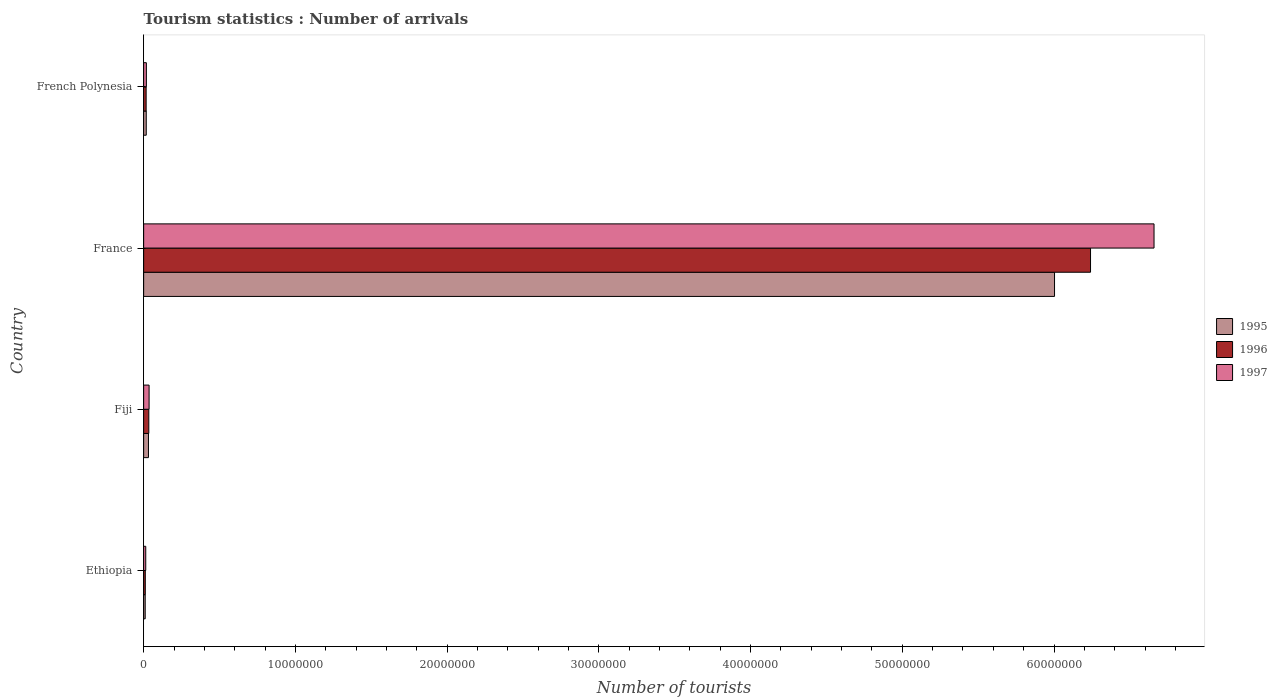Are the number of bars per tick equal to the number of legend labels?
Provide a succinct answer. Yes. How many bars are there on the 4th tick from the top?
Make the answer very short. 3. How many bars are there on the 1st tick from the bottom?
Give a very brief answer. 3. What is the label of the 1st group of bars from the top?
Make the answer very short. French Polynesia. In how many cases, is the number of bars for a given country not equal to the number of legend labels?
Give a very brief answer. 0. What is the number of tourist arrivals in 1995 in France?
Provide a succinct answer. 6.00e+07. Across all countries, what is the maximum number of tourist arrivals in 1996?
Provide a succinct answer. 6.24e+07. Across all countries, what is the minimum number of tourist arrivals in 1995?
Offer a terse response. 1.03e+05. In which country was the number of tourist arrivals in 1996 maximum?
Provide a succinct answer. France. In which country was the number of tourist arrivals in 1995 minimum?
Give a very brief answer. Ethiopia. What is the total number of tourist arrivals in 1996 in the graph?
Offer a terse response. 6.30e+07. What is the difference between the number of tourist arrivals in 1996 in Fiji and that in French Polynesia?
Ensure brevity in your answer.  1.76e+05. What is the difference between the number of tourist arrivals in 1995 in Fiji and the number of tourist arrivals in 1996 in French Polynesia?
Your answer should be very brief. 1.54e+05. What is the average number of tourist arrivals in 1996 per country?
Make the answer very short. 1.58e+07. What is the difference between the number of tourist arrivals in 1996 and number of tourist arrivals in 1995 in Fiji?
Your answer should be very brief. 2.20e+04. What is the ratio of the number of tourist arrivals in 1996 in Ethiopia to that in France?
Your response must be concise. 0. What is the difference between the highest and the second highest number of tourist arrivals in 1997?
Provide a short and direct response. 6.62e+07. What is the difference between the highest and the lowest number of tourist arrivals in 1997?
Your answer should be compact. 6.65e+07. Is the sum of the number of tourist arrivals in 1997 in Fiji and French Polynesia greater than the maximum number of tourist arrivals in 1995 across all countries?
Give a very brief answer. No. How many bars are there?
Your response must be concise. 12. Are all the bars in the graph horizontal?
Ensure brevity in your answer.  Yes. How many countries are there in the graph?
Your answer should be very brief. 4. What is the difference between two consecutive major ticks on the X-axis?
Make the answer very short. 1.00e+07. Does the graph contain grids?
Provide a short and direct response. No. How many legend labels are there?
Give a very brief answer. 3. What is the title of the graph?
Your answer should be very brief. Tourism statistics : Number of arrivals. Does "1973" appear as one of the legend labels in the graph?
Offer a very short reply. No. What is the label or title of the X-axis?
Your response must be concise. Number of tourists. What is the Number of tourists of 1995 in Ethiopia?
Make the answer very short. 1.03e+05. What is the Number of tourists of 1996 in Ethiopia?
Keep it short and to the point. 1.09e+05. What is the Number of tourists of 1997 in Ethiopia?
Keep it short and to the point. 1.39e+05. What is the Number of tourists in 1995 in Fiji?
Ensure brevity in your answer.  3.18e+05. What is the Number of tourists in 1997 in Fiji?
Make the answer very short. 3.59e+05. What is the Number of tourists of 1995 in France?
Give a very brief answer. 6.00e+07. What is the Number of tourists of 1996 in France?
Your answer should be very brief. 6.24e+07. What is the Number of tourists in 1997 in France?
Ensure brevity in your answer.  6.66e+07. What is the Number of tourists of 1995 in French Polynesia?
Offer a terse response. 1.72e+05. What is the Number of tourists of 1996 in French Polynesia?
Provide a succinct answer. 1.64e+05. What is the Number of tourists of 1997 in French Polynesia?
Your response must be concise. 1.80e+05. Across all countries, what is the maximum Number of tourists of 1995?
Provide a short and direct response. 6.00e+07. Across all countries, what is the maximum Number of tourists of 1996?
Make the answer very short. 6.24e+07. Across all countries, what is the maximum Number of tourists in 1997?
Make the answer very short. 6.66e+07. Across all countries, what is the minimum Number of tourists in 1995?
Give a very brief answer. 1.03e+05. Across all countries, what is the minimum Number of tourists in 1996?
Your answer should be very brief. 1.09e+05. Across all countries, what is the minimum Number of tourists in 1997?
Make the answer very short. 1.39e+05. What is the total Number of tourists of 1995 in the graph?
Ensure brevity in your answer.  6.06e+07. What is the total Number of tourists in 1996 in the graph?
Your response must be concise. 6.30e+07. What is the total Number of tourists of 1997 in the graph?
Provide a short and direct response. 6.73e+07. What is the difference between the Number of tourists in 1995 in Ethiopia and that in Fiji?
Your answer should be compact. -2.15e+05. What is the difference between the Number of tourists of 1996 in Ethiopia and that in Fiji?
Your answer should be very brief. -2.31e+05. What is the difference between the Number of tourists in 1995 in Ethiopia and that in France?
Your answer should be very brief. -5.99e+07. What is the difference between the Number of tourists of 1996 in Ethiopia and that in France?
Make the answer very short. -6.23e+07. What is the difference between the Number of tourists of 1997 in Ethiopia and that in France?
Provide a succinct answer. -6.65e+07. What is the difference between the Number of tourists in 1995 in Ethiopia and that in French Polynesia?
Offer a very short reply. -6.90e+04. What is the difference between the Number of tourists of 1996 in Ethiopia and that in French Polynesia?
Keep it short and to the point. -5.50e+04. What is the difference between the Number of tourists in 1997 in Ethiopia and that in French Polynesia?
Give a very brief answer. -4.10e+04. What is the difference between the Number of tourists of 1995 in Fiji and that in France?
Your answer should be compact. -5.97e+07. What is the difference between the Number of tourists in 1996 in Fiji and that in France?
Your response must be concise. -6.21e+07. What is the difference between the Number of tourists in 1997 in Fiji and that in France?
Ensure brevity in your answer.  -6.62e+07. What is the difference between the Number of tourists in 1995 in Fiji and that in French Polynesia?
Your answer should be compact. 1.46e+05. What is the difference between the Number of tourists of 1996 in Fiji and that in French Polynesia?
Keep it short and to the point. 1.76e+05. What is the difference between the Number of tourists of 1997 in Fiji and that in French Polynesia?
Offer a terse response. 1.79e+05. What is the difference between the Number of tourists of 1995 in France and that in French Polynesia?
Provide a short and direct response. 5.99e+07. What is the difference between the Number of tourists in 1996 in France and that in French Polynesia?
Your answer should be very brief. 6.22e+07. What is the difference between the Number of tourists of 1997 in France and that in French Polynesia?
Give a very brief answer. 6.64e+07. What is the difference between the Number of tourists of 1995 in Ethiopia and the Number of tourists of 1996 in Fiji?
Make the answer very short. -2.37e+05. What is the difference between the Number of tourists in 1995 in Ethiopia and the Number of tourists in 1997 in Fiji?
Ensure brevity in your answer.  -2.56e+05. What is the difference between the Number of tourists of 1996 in Ethiopia and the Number of tourists of 1997 in Fiji?
Your answer should be very brief. -2.50e+05. What is the difference between the Number of tourists of 1995 in Ethiopia and the Number of tourists of 1996 in France?
Your answer should be compact. -6.23e+07. What is the difference between the Number of tourists in 1995 in Ethiopia and the Number of tourists in 1997 in France?
Offer a very short reply. -6.65e+07. What is the difference between the Number of tourists of 1996 in Ethiopia and the Number of tourists of 1997 in France?
Give a very brief answer. -6.65e+07. What is the difference between the Number of tourists in 1995 in Ethiopia and the Number of tourists in 1996 in French Polynesia?
Give a very brief answer. -6.10e+04. What is the difference between the Number of tourists in 1995 in Ethiopia and the Number of tourists in 1997 in French Polynesia?
Ensure brevity in your answer.  -7.70e+04. What is the difference between the Number of tourists of 1996 in Ethiopia and the Number of tourists of 1997 in French Polynesia?
Provide a succinct answer. -7.10e+04. What is the difference between the Number of tourists of 1995 in Fiji and the Number of tourists of 1996 in France?
Provide a succinct answer. -6.21e+07. What is the difference between the Number of tourists in 1995 in Fiji and the Number of tourists in 1997 in France?
Provide a short and direct response. -6.63e+07. What is the difference between the Number of tourists of 1996 in Fiji and the Number of tourists of 1997 in France?
Your response must be concise. -6.63e+07. What is the difference between the Number of tourists in 1995 in Fiji and the Number of tourists in 1996 in French Polynesia?
Your response must be concise. 1.54e+05. What is the difference between the Number of tourists of 1995 in Fiji and the Number of tourists of 1997 in French Polynesia?
Ensure brevity in your answer.  1.38e+05. What is the difference between the Number of tourists in 1995 in France and the Number of tourists in 1996 in French Polynesia?
Ensure brevity in your answer.  5.99e+07. What is the difference between the Number of tourists of 1995 in France and the Number of tourists of 1997 in French Polynesia?
Give a very brief answer. 5.99e+07. What is the difference between the Number of tourists in 1996 in France and the Number of tourists in 1997 in French Polynesia?
Ensure brevity in your answer.  6.22e+07. What is the average Number of tourists in 1995 per country?
Your answer should be compact. 1.52e+07. What is the average Number of tourists in 1996 per country?
Your answer should be compact. 1.58e+07. What is the average Number of tourists of 1997 per country?
Offer a terse response. 1.68e+07. What is the difference between the Number of tourists of 1995 and Number of tourists of 1996 in Ethiopia?
Give a very brief answer. -6000. What is the difference between the Number of tourists in 1995 and Number of tourists in 1997 in Ethiopia?
Give a very brief answer. -3.60e+04. What is the difference between the Number of tourists in 1996 and Number of tourists in 1997 in Ethiopia?
Give a very brief answer. -3.00e+04. What is the difference between the Number of tourists of 1995 and Number of tourists of 1996 in Fiji?
Give a very brief answer. -2.20e+04. What is the difference between the Number of tourists in 1995 and Number of tourists in 1997 in Fiji?
Offer a terse response. -4.10e+04. What is the difference between the Number of tourists of 1996 and Number of tourists of 1997 in Fiji?
Offer a terse response. -1.90e+04. What is the difference between the Number of tourists of 1995 and Number of tourists of 1996 in France?
Provide a short and direct response. -2.37e+06. What is the difference between the Number of tourists in 1995 and Number of tourists in 1997 in France?
Your answer should be very brief. -6.56e+06. What is the difference between the Number of tourists in 1996 and Number of tourists in 1997 in France?
Make the answer very short. -4.18e+06. What is the difference between the Number of tourists of 1995 and Number of tourists of 1996 in French Polynesia?
Provide a succinct answer. 8000. What is the difference between the Number of tourists in 1995 and Number of tourists in 1997 in French Polynesia?
Your answer should be very brief. -8000. What is the difference between the Number of tourists of 1996 and Number of tourists of 1997 in French Polynesia?
Give a very brief answer. -1.60e+04. What is the ratio of the Number of tourists of 1995 in Ethiopia to that in Fiji?
Provide a succinct answer. 0.32. What is the ratio of the Number of tourists in 1996 in Ethiopia to that in Fiji?
Keep it short and to the point. 0.32. What is the ratio of the Number of tourists in 1997 in Ethiopia to that in Fiji?
Give a very brief answer. 0.39. What is the ratio of the Number of tourists in 1995 in Ethiopia to that in France?
Your answer should be compact. 0. What is the ratio of the Number of tourists in 1996 in Ethiopia to that in France?
Your answer should be compact. 0. What is the ratio of the Number of tourists of 1997 in Ethiopia to that in France?
Your response must be concise. 0. What is the ratio of the Number of tourists in 1995 in Ethiopia to that in French Polynesia?
Ensure brevity in your answer.  0.6. What is the ratio of the Number of tourists in 1996 in Ethiopia to that in French Polynesia?
Your answer should be very brief. 0.66. What is the ratio of the Number of tourists of 1997 in Ethiopia to that in French Polynesia?
Offer a very short reply. 0.77. What is the ratio of the Number of tourists of 1995 in Fiji to that in France?
Your answer should be compact. 0.01. What is the ratio of the Number of tourists of 1996 in Fiji to that in France?
Provide a succinct answer. 0.01. What is the ratio of the Number of tourists in 1997 in Fiji to that in France?
Your answer should be very brief. 0.01. What is the ratio of the Number of tourists in 1995 in Fiji to that in French Polynesia?
Ensure brevity in your answer.  1.85. What is the ratio of the Number of tourists of 1996 in Fiji to that in French Polynesia?
Offer a very short reply. 2.07. What is the ratio of the Number of tourists in 1997 in Fiji to that in French Polynesia?
Offer a terse response. 1.99. What is the ratio of the Number of tourists in 1995 in France to that in French Polynesia?
Keep it short and to the point. 349.03. What is the ratio of the Number of tourists in 1996 in France to that in French Polynesia?
Offer a very short reply. 380.52. What is the ratio of the Number of tourists in 1997 in France to that in French Polynesia?
Your response must be concise. 369.95. What is the difference between the highest and the second highest Number of tourists of 1995?
Give a very brief answer. 5.97e+07. What is the difference between the highest and the second highest Number of tourists in 1996?
Your answer should be compact. 6.21e+07. What is the difference between the highest and the second highest Number of tourists in 1997?
Give a very brief answer. 6.62e+07. What is the difference between the highest and the lowest Number of tourists of 1995?
Give a very brief answer. 5.99e+07. What is the difference between the highest and the lowest Number of tourists of 1996?
Keep it short and to the point. 6.23e+07. What is the difference between the highest and the lowest Number of tourists of 1997?
Ensure brevity in your answer.  6.65e+07. 